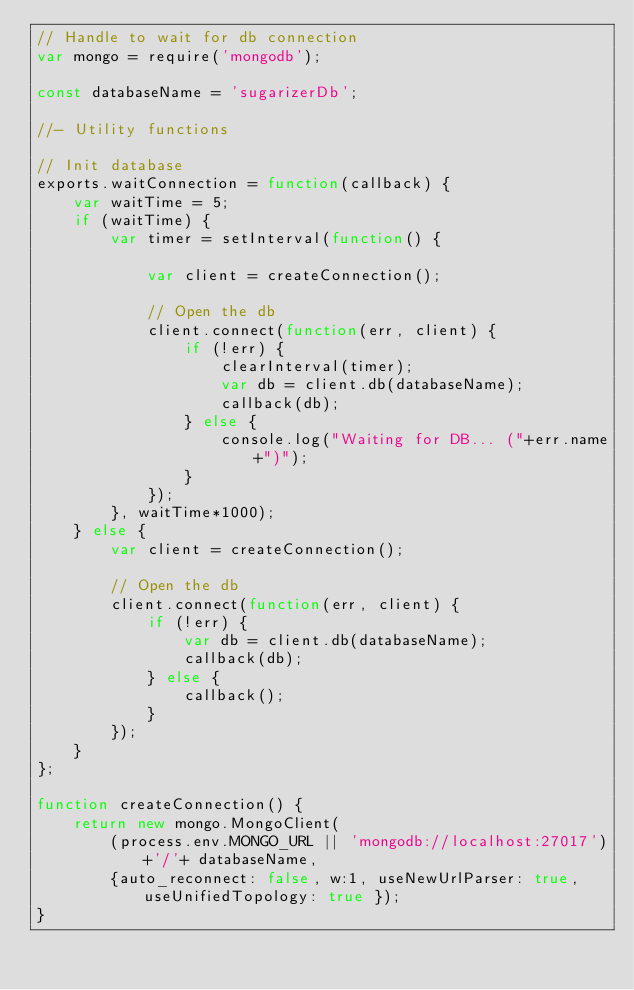<code> <loc_0><loc_0><loc_500><loc_500><_JavaScript_>// Handle to wait for db connection
var mongo = require('mongodb');

const databaseName = 'sugarizerDb';

//- Utility functions

// Init database
exports.waitConnection = function(callback) {
	var waitTime = 5;
	if (waitTime) {
		var timer = setInterval(function() {

			var client = createConnection();

			// Open the db
			client.connect(function(err, client) {
				if (!err) {
                    clearInterval(timer);
                    var db = client.db(databaseName);
					callback(db);
				} else {
					console.log("Waiting for DB... ("+err.name+")");
				}
			});
		}, waitTime*1000);
	} else {
		var client = createConnection();

		// Open the db
		client.connect(function(err, client) {
			if (!err) {
                var db = client.db(databaseName);
				callback(db);
			} else {
				callback();
			}
		});
	}
};

function createConnection() {
	return new mongo.MongoClient(
		(process.env.MONGO_URL || 'mongodb://localhost:27017')+'/'+ databaseName,
		{auto_reconnect: false, w:1, useNewUrlParser: true, useUnifiedTopology: true });
}
</code> 